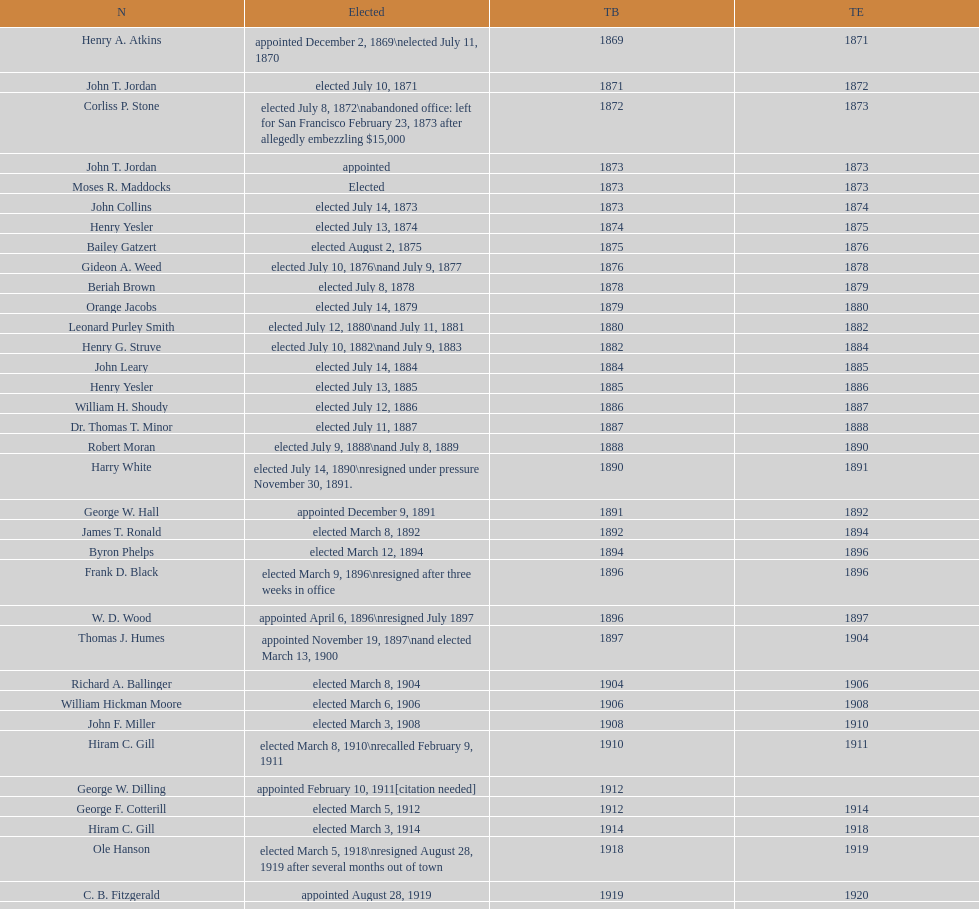Would you be able to parse every entry in this table? {'header': ['N', 'Elected', 'TB', 'TE'], 'rows': [['Henry A. Atkins', 'appointed December 2, 1869\\nelected July 11, 1870', '1869', '1871'], ['John T. Jordan', 'elected July 10, 1871', '1871', '1872'], ['Corliss P. Stone', 'elected July 8, 1872\\nabandoned office: left for San Francisco February 23, 1873 after allegedly embezzling $15,000', '1872', '1873'], ['John T. Jordan', 'appointed', '1873', '1873'], ['Moses R. Maddocks', 'Elected', '1873', '1873'], ['John Collins', 'elected July 14, 1873', '1873', '1874'], ['Henry Yesler', 'elected July 13, 1874', '1874', '1875'], ['Bailey Gatzert', 'elected August 2, 1875', '1875', '1876'], ['Gideon A. Weed', 'elected July 10, 1876\\nand July 9, 1877', '1876', '1878'], ['Beriah Brown', 'elected July 8, 1878', '1878', '1879'], ['Orange Jacobs', 'elected July 14, 1879', '1879', '1880'], ['Leonard Purley Smith', 'elected July 12, 1880\\nand July 11, 1881', '1880', '1882'], ['Henry G. Struve', 'elected July 10, 1882\\nand July 9, 1883', '1882', '1884'], ['John Leary', 'elected July 14, 1884', '1884', '1885'], ['Henry Yesler', 'elected July 13, 1885', '1885', '1886'], ['William H. Shoudy', 'elected July 12, 1886', '1886', '1887'], ['Dr. Thomas T. Minor', 'elected July 11, 1887', '1887', '1888'], ['Robert Moran', 'elected July 9, 1888\\nand July 8, 1889', '1888', '1890'], ['Harry White', 'elected July 14, 1890\\nresigned under pressure November 30, 1891.', '1890', '1891'], ['George W. Hall', 'appointed December 9, 1891', '1891', '1892'], ['James T. Ronald', 'elected March 8, 1892', '1892', '1894'], ['Byron Phelps', 'elected March 12, 1894', '1894', '1896'], ['Frank D. Black', 'elected March 9, 1896\\nresigned after three weeks in office', '1896', '1896'], ['W. D. Wood', 'appointed April 6, 1896\\nresigned July 1897', '1896', '1897'], ['Thomas J. Humes', 'appointed November 19, 1897\\nand elected March 13, 1900', '1897', '1904'], ['Richard A. Ballinger', 'elected March 8, 1904', '1904', '1906'], ['William Hickman Moore', 'elected March 6, 1906', '1906', '1908'], ['John F. Miller', 'elected March 3, 1908', '1908', '1910'], ['Hiram C. Gill', 'elected March 8, 1910\\nrecalled February 9, 1911', '1910', '1911'], ['George W. Dilling', 'appointed February 10, 1911[citation needed]', '1912', ''], ['George F. Cotterill', 'elected March 5, 1912', '1912', '1914'], ['Hiram C. Gill', 'elected March 3, 1914', '1914', '1918'], ['Ole Hanson', 'elected March 5, 1918\\nresigned August 28, 1919 after several months out of town', '1918', '1919'], ['C. B. Fitzgerald', 'appointed August 28, 1919', '1919', '1920'], ['Hugh M. Caldwell', 'elected March 2, 1920', '1920', '1922'], ['Edwin J. Brown', 'elected May 2, 1922\\nand March 4, 1924', '1922', '1926'], ['Bertha Knight Landes', 'elected March 9, 1926', '1926', '1928'], ['Frank E. Edwards', 'elected March 6, 1928\\nand March 4, 1930\\nrecalled July 13, 1931', '1928', '1931'], ['Robert H. Harlin', 'appointed July 14, 1931', '1931', '1932'], ['John F. Dore', 'elected March 8, 1932', '1932', '1934'], ['Charles L. Smith', 'elected March 6, 1934', '1934', '1936'], ['John F. Dore', 'elected March 3, 1936\\nbecame gravely ill and was relieved of office April 13, 1938, already a lame duck after the 1938 election. He died five days later.', '1936', '1938'], ['Arthur B. Langlie', "elected March 8, 1938\\nappointed to take office early, April 27, 1938, after Dore's death.\\nelected March 5, 1940\\nresigned January 11, 1941, to become Governor of Washington", '1938', '1941'], ['John E. Carroll', 'appointed January 27, 1941', '1941', '1941'], ['Earl Millikin', 'elected March 4, 1941', '1941', '1942'], ['William F. Devin', 'elected March 3, 1942, March 7, 1944, March 5, 1946, and March 2, 1948', '1942', '1952'], ['Allan Pomeroy', 'elected March 4, 1952', '1952', '1956'], ['Gordon S. Clinton', 'elected March 6, 1956\\nand March 8, 1960', '1956', '1964'], ["James d'Orma Braman", 'elected March 10, 1964\\nresigned March 23, 1969, to accept an appointment as an Assistant Secretary in the Department of Transportation in the Nixon administration.', '1964', '1969'], ['Floyd C. Miller', 'appointed March 23, 1969', '1969', '1969'], ['Wesley C. Uhlman', 'elected November 4, 1969\\nand November 6, 1973\\nsurvived recall attempt on July 1, 1975', 'December 1, 1969', 'January 1, 1978'], ['Charles Royer', 'elected November 8, 1977, November 3, 1981, and November 5, 1985', 'January 1, 1978', 'January 1, 1990'], ['Norman B. Rice', 'elected November 7, 1989', 'January 1, 1990', 'January 1, 1998'], ['Paul Schell', 'elected November 4, 1997', 'January 1, 1998', 'January 1, 2002'], ['Gregory J. Nickels', 'elected November 6, 2001\\nand November 8, 2005', 'January 1, 2002', 'January 1, 2010'], ['Michael McGinn', 'elected November 3, 2009', 'January 1, 2010', 'January 1, 2014'], ['Ed Murray', 'elected November 5, 2013', 'January 1, 2014', 'present']]} What is the number of mayors with the first name of john? 6. 